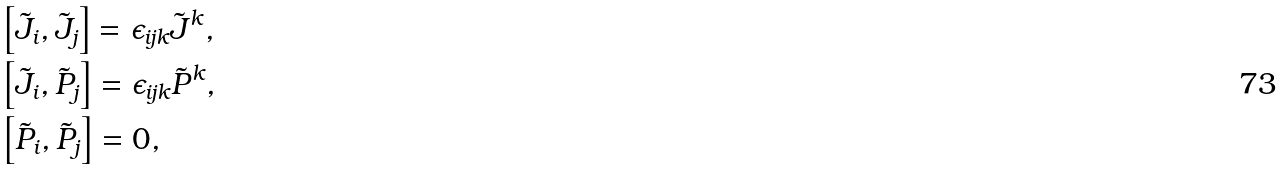<formula> <loc_0><loc_0><loc_500><loc_500>& \left [ \tilde { J } _ { i } , \tilde { J } _ { j } \right ] = \epsilon _ { i j k } \tilde { J } ^ { k } , \\ & \left [ \tilde { J } _ { i } , \tilde { P } _ { j } \right ] = \epsilon _ { i j k } \tilde { P } ^ { k } , \\ & \left [ \tilde { P } _ { i } , \tilde { P } _ { j } \right ] = 0 ,</formula> 